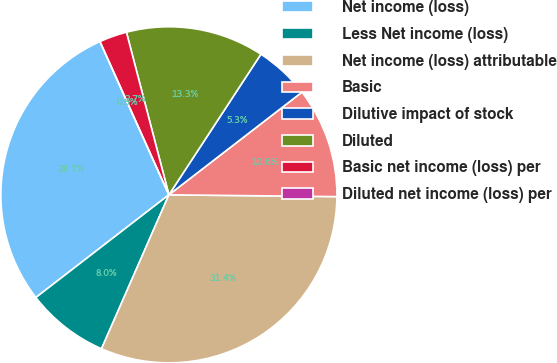Convert chart. <chart><loc_0><loc_0><loc_500><loc_500><pie_chart><fcel>Net income (loss)<fcel>Less Net income (loss)<fcel>Net income (loss) attributable<fcel>Basic<fcel>Dilutive impact of stock<fcel>Diluted<fcel>Basic net income (loss) per<fcel>Diluted net income (loss) per<nl><fcel>28.74%<fcel>7.97%<fcel>31.4%<fcel>10.63%<fcel>5.32%<fcel>13.29%<fcel>2.66%<fcel>0.0%<nl></chart> 